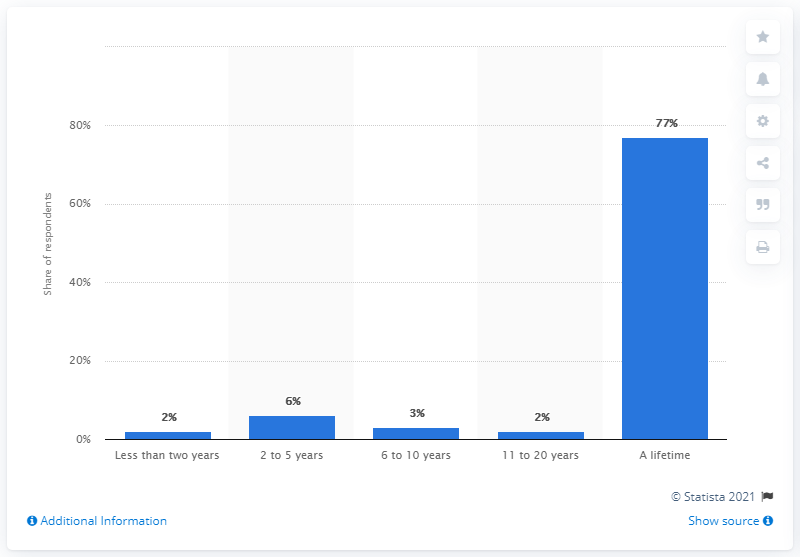Highlight a few significant elements in this photo. A recent survey found that approximately 8% of people believe that the feeling of love lasts for 5 years or less in a relationship. According to a survey, 77% of people believe that the feeling of love can last for a lifetime in a relationship. 